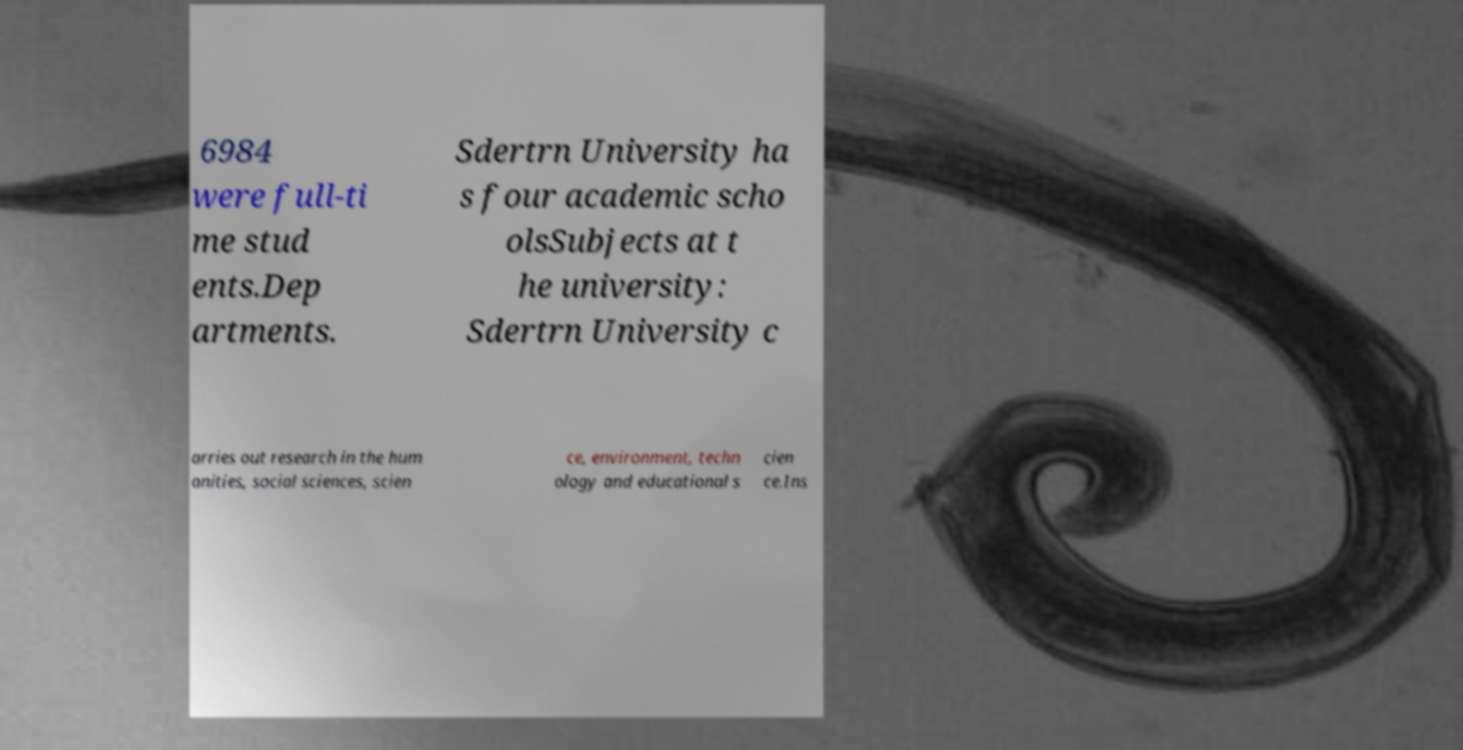For documentation purposes, I need the text within this image transcribed. Could you provide that? 6984 were full-ti me stud ents.Dep artments. Sdertrn University ha s four academic scho olsSubjects at t he university: Sdertrn University c arries out research in the hum anities, social sciences, scien ce, environment, techn ology and educational s cien ce.Ins 